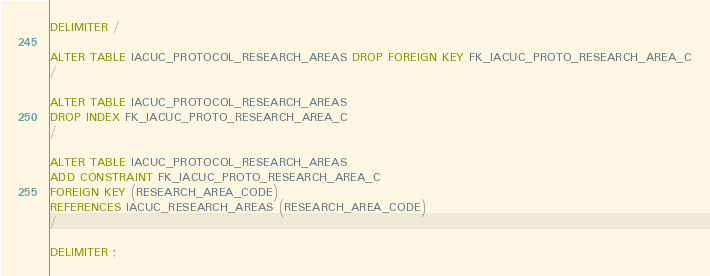<code> <loc_0><loc_0><loc_500><loc_500><_SQL_>DELIMITER /

ALTER TABLE IACUC_PROTOCOL_RESEARCH_AREAS DROP FOREIGN KEY FK_IACUC_PROTO_RESEARCH_AREA_C
/

ALTER TABLE IACUC_PROTOCOL_RESEARCH_AREAS 
DROP INDEX FK_IACUC_PROTO_RESEARCH_AREA_C 
/

ALTER TABLE IACUC_PROTOCOL_RESEARCH_AREAS 
ADD CONSTRAINT FK_IACUC_PROTO_RESEARCH_AREA_C 
FOREIGN KEY (RESEARCH_AREA_CODE) 
REFERENCES IACUC_RESEARCH_AREAS (RESEARCH_AREA_CODE)
/

DELIMITER ;
</code> 